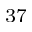<formula> <loc_0><loc_0><loc_500><loc_500>^ { 3 7 }</formula> 